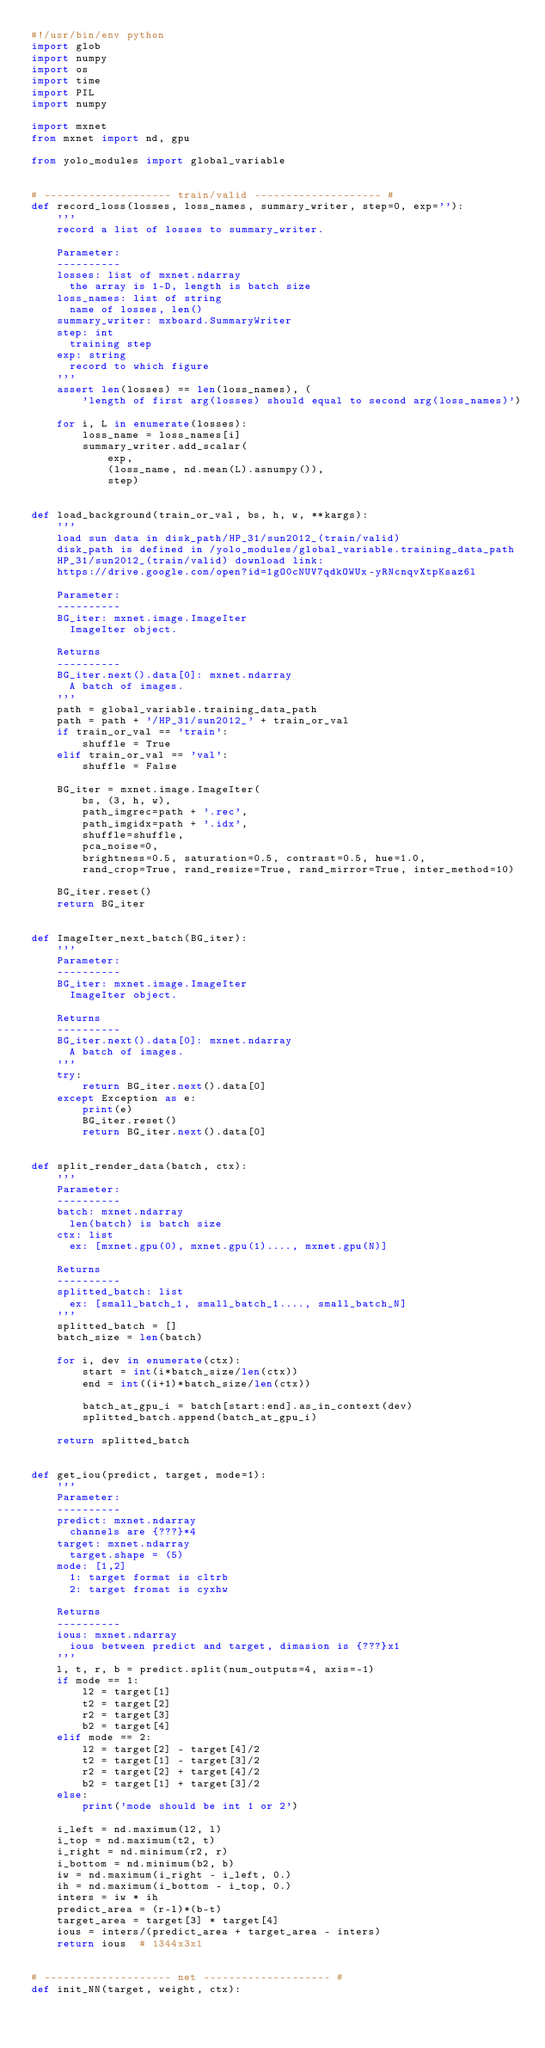Convert code to text. <code><loc_0><loc_0><loc_500><loc_500><_Python_>#!/usr/bin/env python
import glob
import numpy
import os
import time
import PIL
import numpy

import mxnet
from mxnet import nd, gpu

from yolo_modules import global_variable


# -------------------- train/valid -------------------- #
def record_loss(losses, loss_names, summary_writer, step=0, exp=''):
    '''
    record a list of losses to summary_writer.

    Parameter:
    ----------
    losses: list of mxnet.ndarray
      the array is 1-D, length is batch size
    loss_names: list of string
      name of losses, len()
    summary_writer: mxboard.SummaryWriter
    step: int
      training step
    exp: string
      record to which figure
    '''
    assert len(losses) == len(loss_names), (
        'length of first arg(losses) should equal to second arg(loss_names)')

    for i, L in enumerate(losses):
        loss_name = loss_names[i]
        summary_writer.add_scalar(
            exp,
            (loss_name, nd.mean(L).asnumpy()),
            step)


def load_background(train_or_val, bs, h, w, **kargs):
    '''
    load sun data in disk_path/HP_31/sun2012_(train/valid)
    disk_path is defined in /yolo_modules/global_variable.training_data_path
    HP_31/sun2012_(train/valid) download link:
    https://drive.google.com/open?id=1gO0cNUV7qdkOWUx-yRNcnqvXtpKsaz6l

    Parameter:
    ----------
    BG_iter: mxnet.image.ImageIter
      ImageIter object.

    Returns
    ----------
    BG_iter.next().data[0]: mxnet.ndarray
      A batch of images.
    '''
    path = global_variable.training_data_path
    path = path + '/HP_31/sun2012_' + train_or_val
    if train_or_val == 'train':
        shuffle = True
    elif train_or_val == 'val':
        shuffle = False

    BG_iter = mxnet.image.ImageIter(
        bs, (3, h, w),
        path_imgrec=path + '.rec',
        path_imgidx=path + '.idx',
        shuffle=shuffle,
        pca_noise=0,
        brightness=0.5, saturation=0.5, contrast=0.5, hue=1.0,
        rand_crop=True, rand_resize=True, rand_mirror=True, inter_method=10)

    BG_iter.reset()
    return BG_iter


def ImageIter_next_batch(BG_iter):
    '''
    Parameter:
    ----------
    BG_iter: mxnet.image.ImageIter
      ImageIter object.

    Returns
    ----------
    BG_iter.next().data[0]: mxnet.ndarray
      A batch of images.
    '''
    try:
        return BG_iter.next().data[0]
    except Exception as e:
        print(e)
        BG_iter.reset()
        return BG_iter.next().data[0]


def split_render_data(batch, ctx):
    '''
    Parameter:
    ----------
    batch: mxnet.ndarray
      len(batch) is batch size
    ctx: list
      ex: [mxnet.gpu(0), mxnet.gpu(1)...., mxnet.gpu(N)]

    Returns
    ----------
    splitted_batch: list
      ex: [small_batch_1, small_batch_1...., small_batch_N]
    '''
    splitted_batch = []
    batch_size = len(batch)

    for i, dev in enumerate(ctx):
        start = int(i*batch_size/len(ctx))
        end = int((i+1)*batch_size/len(ctx))

        batch_at_gpu_i = batch[start:end].as_in_context(dev)
        splitted_batch.append(batch_at_gpu_i)

    return splitted_batch


def get_iou(predict, target, mode=1):
    '''
    Parameter:
    ----------
    predict: mxnet.ndarray
      channels are {???}*4
    target: mxnet.ndarray
      target.shape = (5)
    mode: [1,2]
      1: target format is cltrb
      2: target fromat is cyxhw

    Returns
    ----------
    ious: mxnet.ndarray
      ious between predict and target, dimasion is {???}x1
    '''
    l, t, r, b = predict.split(num_outputs=4, axis=-1)
    if mode == 1:
        l2 = target[1]
        t2 = target[2]
        r2 = target[3]
        b2 = target[4]
    elif mode == 2:
        l2 = target[2] - target[4]/2
        t2 = target[1] - target[3]/2
        r2 = target[2] + target[4]/2
        b2 = target[1] + target[3]/2
    else:
        print('mode should be int 1 or 2')

    i_left = nd.maximum(l2, l)
    i_top = nd.maximum(t2, t)
    i_right = nd.minimum(r2, r)
    i_bottom = nd.minimum(b2, b)
    iw = nd.maximum(i_right - i_left, 0.)
    ih = nd.maximum(i_bottom - i_top, 0.)
    inters = iw * ih
    predict_area = (r-l)*(b-t)
    target_area = target[3] * target[4]
    ious = inters/(predict_area + target_area - inters)
    return ious  # 1344x3x1


# -------------------- net -------------------- #
def init_NN(target, weight, ctx):</code> 